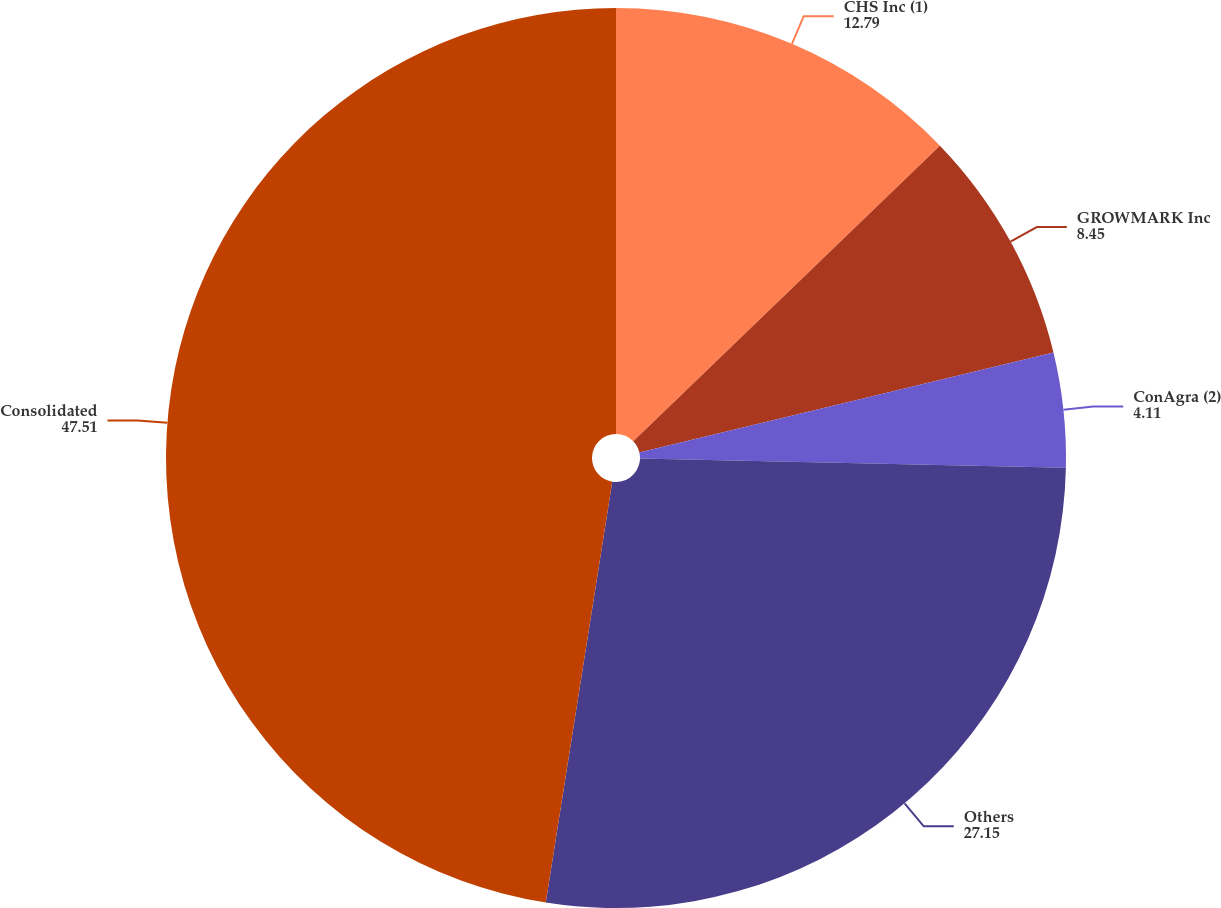Convert chart to OTSL. <chart><loc_0><loc_0><loc_500><loc_500><pie_chart><fcel>CHS Inc (1)<fcel>GROWMARK Inc<fcel>ConAgra (2)<fcel>Others<fcel>Consolidated<nl><fcel>12.79%<fcel>8.45%<fcel>4.11%<fcel>27.15%<fcel>47.51%<nl></chart> 